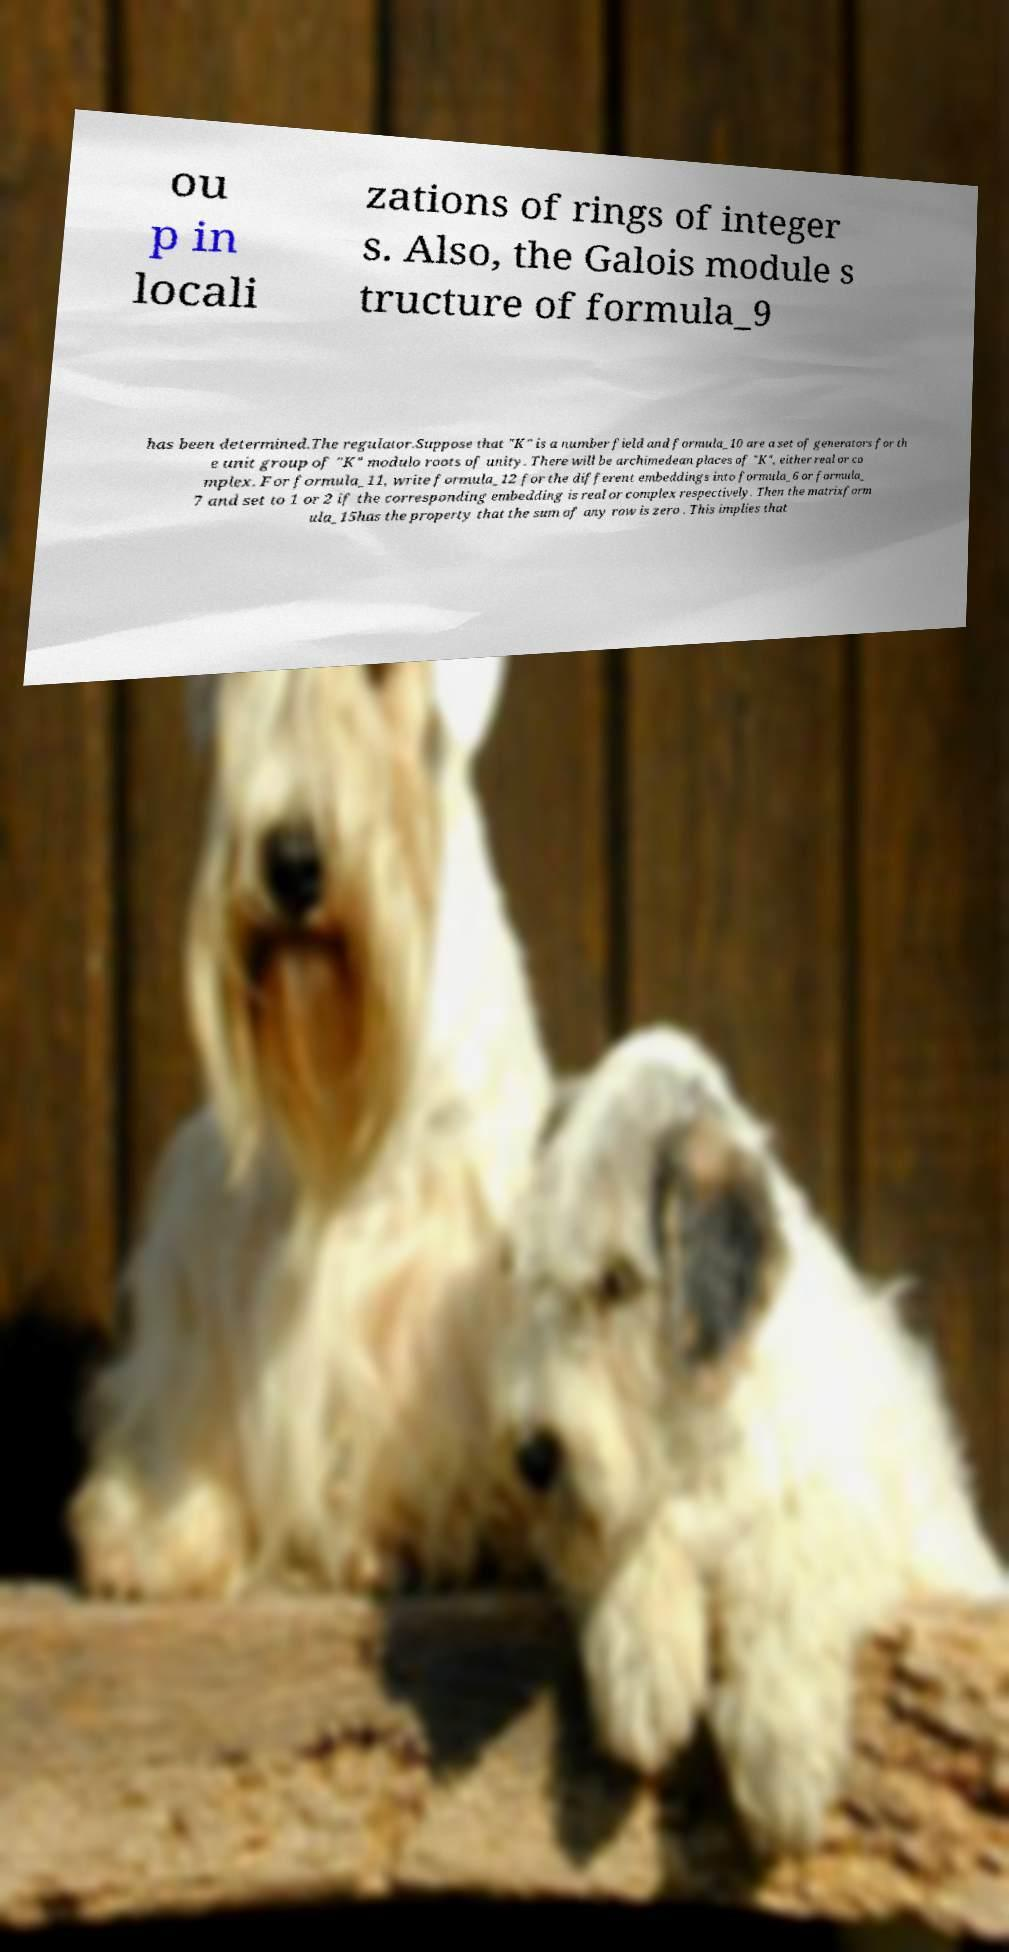Can you accurately transcribe the text from the provided image for me? ou p in locali zations of rings of integer s. Also, the Galois module s tructure of formula_9 has been determined.The regulator.Suppose that "K" is a number field and formula_10 are a set of generators for th e unit group of "K" modulo roots of unity. There will be archimedean places of "K", either real or co mplex. For formula_11, write formula_12 for the different embeddings into formula_6 or formula_ 7 and set to 1 or 2 if the corresponding embedding is real or complex respectively. Then the matrixform ula_15has the property that the sum of any row is zero . This implies that 